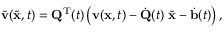<formula> <loc_0><loc_0><loc_500><loc_500>\widetilde { \mathbf v } ( \widetilde { \mathbf x } , t ) = { \mathbf Q } ^ { \mathrm T } ( t ) \left ( { \mathbf v } ( { \mathbf x } , t ) - \dot { \mathbf Q } ( t ) \, \widetilde { \mathbf x } - \dot { \mathbf b } ( t ) \right ) ,</formula> 